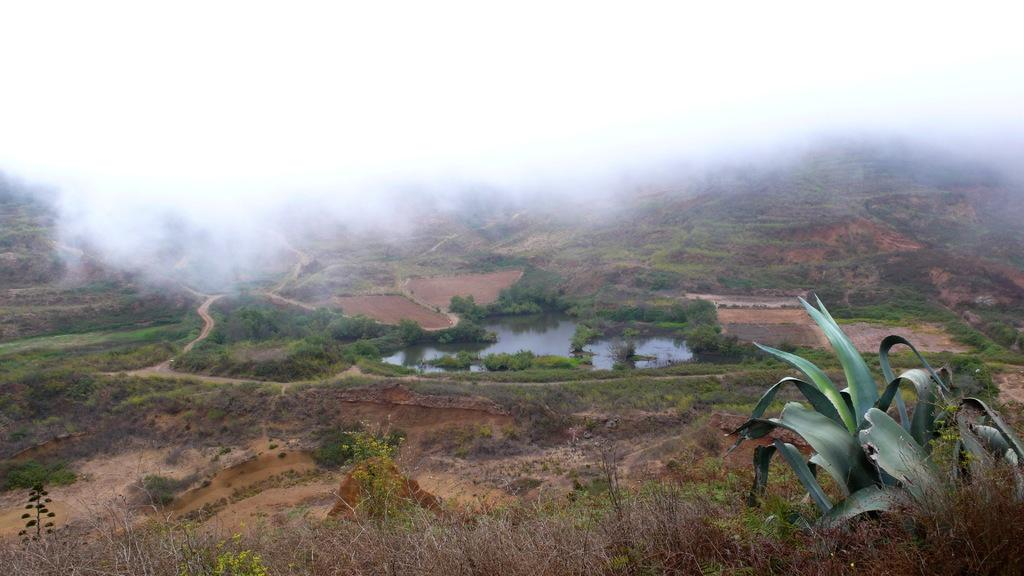What type of natural feature can be seen in the image? There is a water body in the image. What type of vegetation is present in the image? There is a group of trees, plants, and grass in the image. Is there any man-made feature in the image? Yes, there is a pathway in the image. What is the distribution of base elements in the image? The provided facts do not mention any base elements, so it is not possible to determine their distribution in the image. 